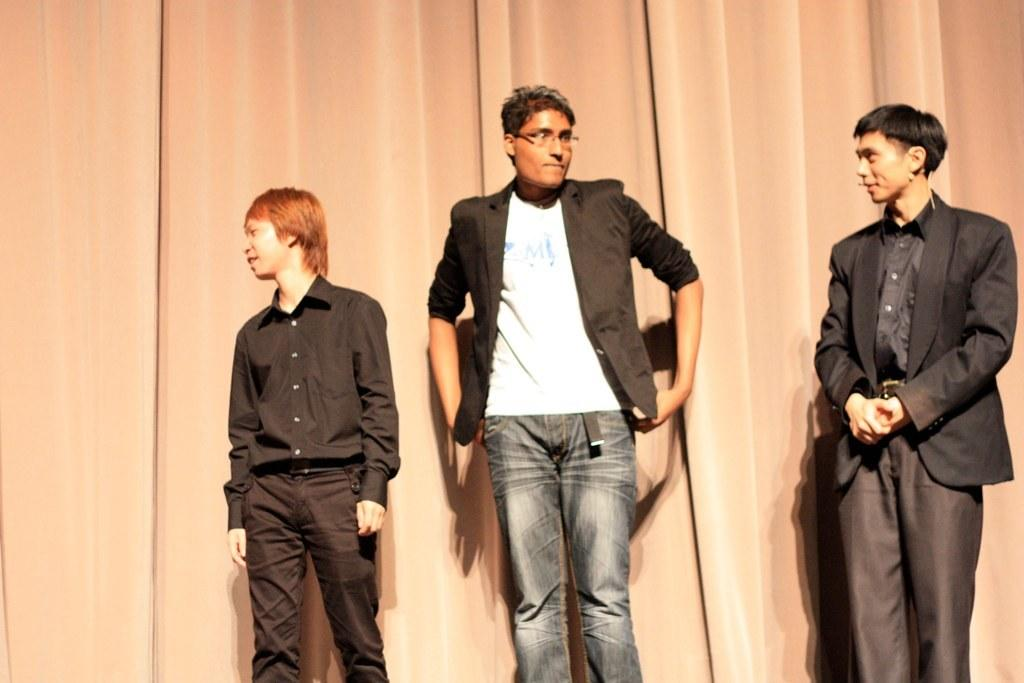How many men are present in the image? There are three men standing in the image. Can you describe the position of the man on the right? The man on the right is standing to the right. What is the man on the right wearing? The man on the right is wearing a microphone around his ear. What can be seen in the background of the image? There is a curtain visible in the image. What type of work does the actor on the left perform in the image? There is no actor present in the image, and therefore no specific work can be attributed to them. 